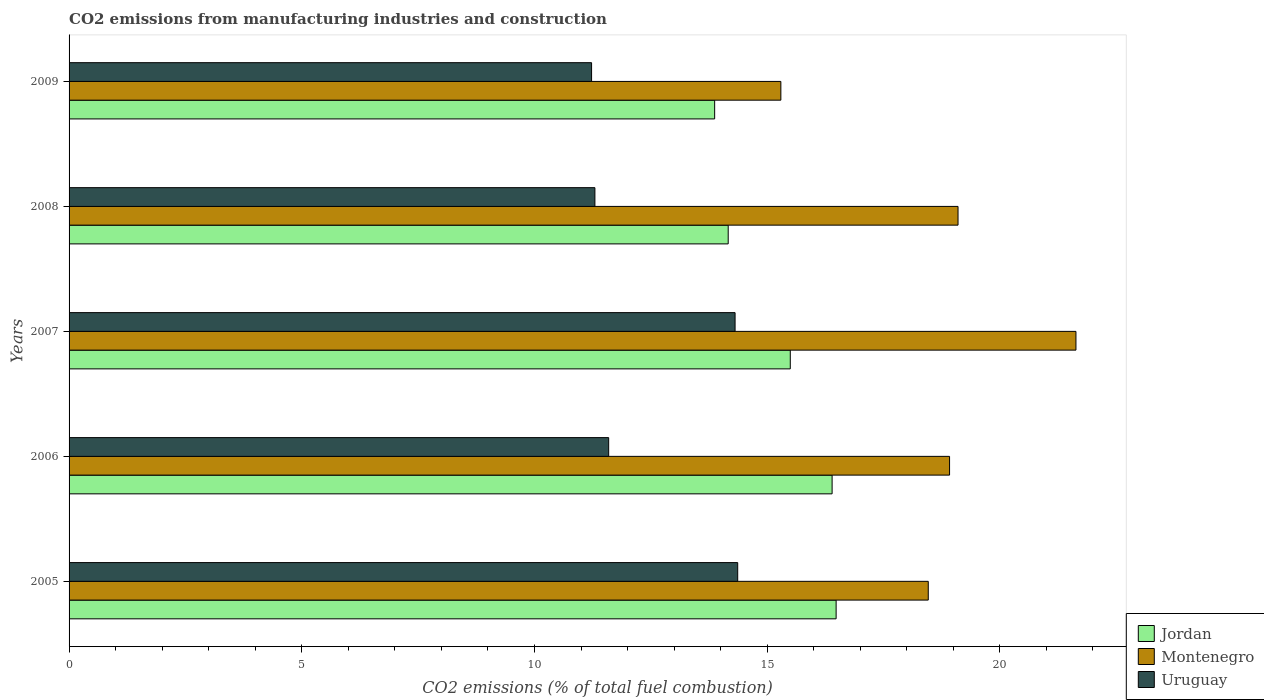How many different coloured bars are there?
Keep it short and to the point. 3. How many bars are there on the 5th tick from the top?
Your answer should be very brief. 3. How many bars are there on the 1st tick from the bottom?
Offer a very short reply. 3. What is the label of the 3rd group of bars from the top?
Offer a terse response. 2007. In how many cases, is the number of bars for a given year not equal to the number of legend labels?
Your answer should be very brief. 0. What is the amount of CO2 emitted in Uruguay in 2008?
Make the answer very short. 11.3. Across all years, what is the maximum amount of CO2 emitted in Jordan?
Make the answer very short. 16.48. Across all years, what is the minimum amount of CO2 emitted in Montenegro?
Offer a very short reply. 15.29. In which year was the amount of CO2 emitted in Jordan minimum?
Keep it short and to the point. 2009. What is the total amount of CO2 emitted in Uruguay in the graph?
Your response must be concise. 62.8. What is the difference between the amount of CO2 emitted in Uruguay in 2008 and that in 2009?
Your response must be concise. 0.07. What is the difference between the amount of CO2 emitted in Uruguay in 2006 and the amount of CO2 emitted in Montenegro in 2005?
Keep it short and to the point. -6.87. What is the average amount of CO2 emitted in Montenegro per year?
Keep it short and to the point. 18.68. In the year 2007, what is the difference between the amount of CO2 emitted in Jordan and amount of CO2 emitted in Uruguay?
Offer a terse response. 1.19. What is the ratio of the amount of CO2 emitted in Montenegro in 2005 to that in 2008?
Give a very brief answer. 0.97. Is the amount of CO2 emitted in Uruguay in 2006 less than that in 2008?
Give a very brief answer. No. What is the difference between the highest and the second highest amount of CO2 emitted in Montenegro?
Give a very brief answer. 2.53. What is the difference between the highest and the lowest amount of CO2 emitted in Jordan?
Offer a very short reply. 2.61. Is the sum of the amount of CO2 emitted in Uruguay in 2006 and 2009 greater than the maximum amount of CO2 emitted in Jordan across all years?
Keep it short and to the point. Yes. What does the 2nd bar from the top in 2009 represents?
Your response must be concise. Montenegro. What does the 1st bar from the bottom in 2007 represents?
Provide a short and direct response. Jordan. Are all the bars in the graph horizontal?
Offer a terse response. Yes. Are the values on the major ticks of X-axis written in scientific E-notation?
Keep it short and to the point. No. Does the graph contain any zero values?
Give a very brief answer. No. Does the graph contain grids?
Your response must be concise. No. Where does the legend appear in the graph?
Give a very brief answer. Bottom right. What is the title of the graph?
Make the answer very short. CO2 emissions from manufacturing industries and construction. Does "Turkmenistan" appear as one of the legend labels in the graph?
Keep it short and to the point. No. What is the label or title of the X-axis?
Your answer should be very brief. CO2 emissions (% of total fuel combustion). What is the label or title of the Y-axis?
Make the answer very short. Years. What is the CO2 emissions (% of total fuel combustion) in Jordan in 2005?
Your response must be concise. 16.48. What is the CO2 emissions (% of total fuel combustion) in Montenegro in 2005?
Make the answer very short. 18.46. What is the CO2 emissions (% of total fuel combustion) in Uruguay in 2005?
Make the answer very short. 14.37. What is the CO2 emissions (% of total fuel combustion) in Jordan in 2006?
Provide a succinct answer. 16.4. What is the CO2 emissions (% of total fuel combustion) of Montenegro in 2006?
Offer a terse response. 18.92. What is the CO2 emissions (% of total fuel combustion) of Uruguay in 2006?
Provide a short and direct response. 11.59. What is the CO2 emissions (% of total fuel combustion) of Jordan in 2007?
Keep it short and to the point. 15.5. What is the CO2 emissions (% of total fuel combustion) in Montenegro in 2007?
Keep it short and to the point. 21.63. What is the CO2 emissions (% of total fuel combustion) of Uruguay in 2007?
Offer a very short reply. 14.31. What is the CO2 emissions (% of total fuel combustion) of Jordan in 2008?
Keep it short and to the point. 14.16. What is the CO2 emissions (% of total fuel combustion) of Montenegro in 2008?
Provide a short and direct response. 19.1. What is the CO2 emissions (% of total fuel combustion) in Uruguay in 2008?
Keep it short and to the point. 11.3. What is the CO2 emissions (% of total fuel combustion) of Jordan in 2009?
Offer a very short reply. 13.87. What is the CO2 emissions (% of total fuel combustion) in Montenegro in 2009?
Provide a succinct answer. 15.29. What is the CO2 emissions (% of total fuel combustion) in Uruguay in 2009?
Provide a succinct answer. 11.23. Across all years, what is the maximum CO2 emissions (% of total fuel combustion) in Jordan?
Offer a terse response. 16.48. Across all years, what is the maximum CO2 emissions (% of total fuel combustion) of Montenegro?
Keep it short and to the point. 21.63. Across all years, what is the maximum CO2 emissions (% of total fuel combustion) in Uruguay?
Your answer should be compact. 14.37. Across all years, what is the minimum CO2 emissions (% of total fuel combustion) of Jordan?
Give a very brief answer. 13.87. Across all years, what is the minimum CO2 emissions (% of total fuel combustion) of Montenegro?
Keep it short and to the point. 15.29. Across all years, what is the minimum CO2 emissions (% of total fuel combustion) of Uruguay?
Your answer should be very brief. 11.23. What is the total CO2 emissions (% of total fuel combustion) in Jordan in the graph?
Offer a very short reply. 76.41. What is the total CO2 emissions (% of total fuel combustion) in Montenegro in the graph?
Keep it short and to the point. 93.41. What is the total CO2 emissions (% of total fuel combustion) in Uruguay in the graph?
Your answer should be very brief. 62.8. What is the difference between the CO2 emissions (% of total fuel combustion) in Jordan in 2005 and that in 2006?
Ensure brevity in your answer.  0.09. What is the difference between the CO2 emissions (% of total fuel combustion) of Montenegro in 2005 and that in 2006?
Offer a terse response. -0.46. What is the difference between the CO2 emissions (% of total fuel combustion) of Uruguay in 2005 and that in 2006?
Your answer should be compact. 2.77. What is the difference between the CO2 emissions (% of total fuel combustion) of Jordan in 2005 and that in 2007?
Make the answer very short. 0.99. What is the difference between the CO2 emissions (% of total fuel combustion) in Montenegro in 2005 and that in 2007?
Your answer should be very brief. -3.17. What is the difference between the CO2 emissions (% of total fuel combustion) of Uruguay in 2005 and that in 2007?
Offer a very short reply. 0.06. What is the difference between the CO2 emissions (% of total fuel combustion) in Jordan in 2005 and that in 2008?
Offer a terse response. 2.32. What is the difference between the CO2 emissions (% of total fuel combustion) in Montenegro in 2005 and that in 2008?
Ensure brevity in your answer.  -0.64. What is the difference between the CO2 emissions (% of total fuel combustion) in Uruguay in 2005 and that in 2008?
Ensure brevity in your answer.  3.07. What is the difference between the CO2 emissions (% of total fuel combustion) in Jordan in 2005 and that in 2009?
Your answer should be compact. 2.61. What is the difference between the CO2 emissions (% of total fuel combustion) in Montenegro in 2005 and that in 2009?
Make the answer very short. 3.17. What is the difference between the CO2 emissions (% of total fuel combustion) of Uruguay in 2005 and that in 2009?
Make the answer very short. 3.14. What is the difference between the CO2 emissions (% of total fuel combustion) of Jordan in 2006 and that in 2007?
Give a very brief answer. 0.9. What is the difference between the CO2 emissions (% of total fuel combustion) in Montenegro in 2006 and that in 2007?
Your answer should be very brief. -2.72. What is the difference between the CO2 emissions (% of total fuel combustion) of Uruguay in 2006 and that in 2007?
Make the answer very short. -2.72. What is the difference between the CO2 emissions (% of total fuel combustion) in Jordan in 2006 and that in 2008?
Provide a short and direct response. 2.23. What is the difference between the CO2 emissions (% of total fuel combustion) in Montenegro in 2006 and that in 2008?
Offer a terse response. -0.18. What is the difference between the CO2 emissions (% of total fuel combustion) of Uruguay in 2006 and that in 2008?
Provide a succinct answer. 0.3. What is the difference between the CO2 emissions (% of total fuel combustion) in Jordan in 2006 and that in 2009?
Your answer should be compact. 2.52. What is the difference between the CO2 emissions (% of total fuel combustion) of Montenegro in 2006 and that in 2009?
Ensure brevity in your answer.  3.62. What is the difference between the CO2 emissions (% of total fuel combustion) of Uruguay in 2006 and that in 2009?
Offer a terse response. 0.37. What is the difference between the CO2 emissions (% of total fuel combustion) of Jordan in 2007 and that in 2008?
Ensure brevity in your answer.  1.33. What is the difference between the CO2 emissions (% of total fuel combustion) of Montenegro in 2007 and that in 2008?
Provide a short and direct response. 2.53. What is the difference between the CO2 emissions (% of total fuel combustion) in Uruguay in 2007 and that in 2008?
Provide a succinct answer. 3.01. What is the difference between the CO2 emissions (% of total fuel combustion) in Jordan in 2007 and that in 2009?
Offer a terse response. 1.62. What is the difference between the CO2 emissions (% of total fuel combustion) in Montenegro in 2007 and that in 2009?
Ensure brevity in your answer.  6.34. What is the difference between the CO2 emissions (% of total fuel combustion) of Uruguay in 2007 and that in 2009?
Offer a terse response. 3.08. What is the difference between the CO2 emissions (% of total fuel combustion) of Jordan in 2008 and that in 2009?
Keep it short and to the point. 0.29. What is the difference between the CO2 emissions (% of total fuel combustion) of Montenegro in 2008 and that in 2009?
Keep it short and to the point. 3.81. What is the difference between the CO2 emissions (% of total fuel combustion) of Uruguay in 2008 and that in 2009?
Keep it short and to the point. 0.07. What is the difference between the CO2 emissions (% of total fuel combustion) of Jordan in 2005 and the CO2 emissions (% of total fuel combustion) of Montenegro in 2006?
Give a very brief answer. -2.44. What is the difference between the CO2 emissions (% of total fuel combustion) of Jordan in 2005 and the CO2 emissions (% of total fuel combustion) of Uruguay in 2006?
Give a very brief answer. 4.89. What is the difference between the CO2 emissions (% of total fuel combustion) in Montenegro in 2005 and the CO2 emissions (% of total fuel combustion) in Uruguay in 2006?
Ensure brevity in your answer.  6.87. What is the difference between the CO2 emissions (% of total fuel combustion) in Jordan in 2005 and the CO2 emissions (% of total fuel combustion) in Montenegro in 2007?
Your response must be concise. -5.15. What is the difference between the CO2 emissions (% of total fuel combustion) of Jordan in 2005 and the CO2 emissions (% of total fuel combustion) of Uruguay in 2007?
Make the answer very short. 2.17. What is the difference between the CO2 emissions (% of total fuel combustion) of Montenegro in 2005 and the CO2 emissions (% of total fuel combustion) of Uruguay in 2007?
Offer a very short reply. 4.15. What is the difference between the CO2 emissions (% of total fuel combustion) in Jordan in 2005 and the CO2 emissions (% of total fuel combustion) in Montenegro in 2008?
Your response must be concise. -2.62. What is the difference between the CO2 emissions (% of total fuel combustion) in Jordan in 2005 and the CO2 emissions (% of total fuel combustion) in Uruguay in 2008?
Give a very brief answer. 5.18. What is the difference between the CO2 emissions (% of total fuel combustion) in Montenegro in 2005 and the CO2 emissions (% of total fuel combustion) in Uruguay in 2008?
Ensure brevity in your answer.  7.16. What is the difference between the CO2 emissions (% of total fuel combustion) of Jordan in 2005 and the CO2 emissions (% of total fuel combustion) of Montenegro in 2009?
Your response must be concise. 1.19. What is the difference between the CO2 emissions (% of total fuel combustion) of Jordan in 2005 and the CO2 emissions (% of total fuel combustion) of Uruguay in 2009?
Keep it short and to the point. 5.25. What is the difference between the CO2 emissions (% of total fuel combustion) of Montenegro in 2005 and the CO2 emissions (% of total fuel combustion) of Uruguay in 2009?
Your answer should be compact. 7.23. What is the difference between the CO2 emissions (% of total fuel combustion) in Jordan in 2006 and the CO2 emissions (% of total fuel combustion) in Montenegro in 2007?
Provide a succinct answer. -5.24. What is the difference between the CO2 emissions (% of total fuel combustion) in Jordan in 2006 and the CO2 emissions (% of total fuel combustion) in Uruguay in 2007?
Offer a terse response. 2.08. What is the difference between the CO2 emissions (% of total fuel combustion) in Montenegro in 2006 and the CO2 emissions (% of total fuel combustion) in Uruguay in 2007?
Your answer should be compact. 4.61. What is the difference between the CO2 emissions (% of total fuel combustion) in Jordan in 2006 and the CO2 emissions (% of total fuel combustion) in Montenegro in 2008?
Provide a short and direct response. -2.71. What is the difference between the CO2 emissions (% of total fuel combustion) in Jordan in 2006 and the CO2 emissions (% of total fuel combustion) in Uruguay in 2008?
Your response must be concise. 5.1. What is the difference between the CO2 emissions (% of total fuel combustion) in Montenegro in 2006 and the CO2 emissions (% of total fuel combustion) in Uruguay in 2008?
Provide a succinct answer. 7.62. What is the difference between the CO2 emissions (% of total fuel combustion) in Jordan in 2006 and the CO2 emissions (% of total fuel combustion) in Montenegro in 2009?
Your answer should be compact. 1.1. What is the difference between the CO2 emissions (% of total fuel combustion) of Jordan in 2006 and the CO2 emissions (% of total fuel combustion) of Uruguay in 2009?
Offer a terse response. 5.17. What is the difference between the CO2 emissions (% of total fuel combustion) in Montenegro in 2006 and the CO2 emissions (% of total fuel combustion) in Uruguay in 2009?
Your answer should be compact. 7.69. What is the difference between the CO2 emissions (% of total fuel combustion) of Jordan in 2007 and the CO2 emissions (% of total fuel combustion) of Montenegro in 2008?
Offer a very short reply. -3.6. What is the difference between the CO2 emissions (% of total fuel combustion) in Jordan in 2007 and the CO2 emissions (% of total fuel combustion) in Uruguay in 2008?
Your answer should be very brief. 4.2. What is the difference between the CO2 emissions (% of total fuel combustion) of Montenegro in 2007 and the CO2 emissions (% of total fuel combustion) of Uruguay in 2008?
Provide a succinct answer. 10.34. What is the difference between the CO2 emissions (% of total fuel combustion) in Jordan in 2007 and the CO2 emissions (% of total fuel combustion) in Montenegro in 2009?
Offer a very short reply. 0.2. What is the difference between the CO2 emissions (% of total fuel combustion) in Jordan in 2007 and the CO2 emissions (% of total fuel combustion) in Uruguay in 2009?
Your answer should be very brief. 4.27. What is the difference between the CO2 emissions (% of total fuel combustion) in Montenegro in 2007 and the CO2 emissions (% of total fuel combustion) in Uruguay in 2009?
Give a very brief answer. 10.41. What is the difference between the CO2 emissions (% of total fuel combustion) in Jordan in 2008 and the CO2 emissions (% of total fuel combustion) in Montenegro in 2009?
Your response must be concise. -1.13. What is the difference between the CO2 emissions (% of total fuel combustion) of Jordan in 2008 and the CO2 emissions (% of total fuel combustion) of Uruguay in 2009?
Keep it short and to the point. 2.94. What is the difference between the CO2 emissions (% of total fuel combustion) of Montenegro in 2008 and the CO2 emissions (% of total fuel combustion) of Uruguay in 2009?
Offer a terse response. 7.87. What is the average CO2 emissions (% of total fuel combustion) of Jordan per year?
Offer a very short reply. 15.28. What is the average CO2 emissions (% of total fuel combustion) in Montenegro per year?
Your response must be concise. 18.68. What is the average CO2 emissions (% of total fuel combustion) of Uruguay per year?
Your answer should be compact. 12.56. In the year 2005, what is the difference between the CO2 emissions (% of total fuel combustion) of Jordan and CO2 emissions (% of total fuel combustion) of Montenegro?
Your response must be concise. -1.98. In the year 2005, what is the difference between the CO2 emissions (% of total fuel combustion) of Jordan and CO2 emissions (% of total fuel combustion) of Uruguay?
Provide a short and direct response. 2.12. In the year 2005, what is the difference between the CO2 emissions (% of total fuel combustion) of Montenegro and CO2 emissions (% of total fuel combustion) of Uruguay?
Provide a succinct answer. 4.09. In the year 2006, what is the difference between the CO2 emissions (% of total fuel combustion) of Jordan and CO2 emissions (% of total fuel combustion) of Montenegro?
Ensure brevity in your answer.  -2.52. In the year 2006, what is the difference between the CO2 emissions (% of total fuel combustion) in Jordan and CO2 emissions (% of total fuel combustion) in Uruguay?
Offer a very short reply. 4.8. In the year 2006, what is the difference between the CO2 emissions (% of total fuel combustion) of Montenegro and CO2 emissions (% of total fuel combustion) of Uruguay?
Ensure brevity in your answer.  7.32. In the year 2007, what is the difference between the CO2 emissions (% of total fuel combustion) of Jordan and CO2 emissions (% of total fuel combustion) of Montenegro?
Keep it short and to the point. -6.14. In the year 2007, what is the difference between the CO2 emissions (% of total fuel combustion) in Jordan and CO2 emissions (% of total fuel combustion) in Uruguay?
Offer a very short reply. 1.19. In the year 2007, what is the difference between the CO2 emissions (% of total fuel combustion) of Montenegro and CO2 emissions (% of total fuel combustion) of Uruguay?
Make the answer very short. 7.32. In the year 2008, what is the difference between the CO2 emissions (% of total fuel combustion) in Jordan and CO2 emissions (% of total fuel combustion) in Montenegro?
Give a very brief answer. -4.94. In the year 2008, what is the difference between the CO2 emissions (% of total fuel combustion) of Jordan and CO2 emissions (% of total fuel combustion) of Uruguay?
Offer a terse response. 2.86. In the year 2008, what is the difference between the CO2 emissions (% of total fuel combustion) of Montenegro and CO2 emissions (% of total fuel combustion) of Uruguay?
Offer a very short reply. 7.8. In the year 2009, what is the difference between the CO2 emissions (% of total fuel combustion) in Jordan and CO2 emissions (% of total fuel combustion) in Montenegro?
Keep it short and to the point. -1.42. In the year 2009, what is the difference between the CO2 emissions (% of total fuel combustion) in Jordan and CO2 emissions (% of total fuel combustion) in Uruguay?
Your answer should be very brief. 2.64. In the year 2009, what is the difference between the CO2 emissions (% of total fuel combustion) of Montenegro and CO2 emissions (% of total fuel combustion) of Uruguay?
Offer a very short reply. 4.07. What is the ratio of the CO2 emissions (% of total fuel combustion) in Montenegro in 2005 to that in 2006?
Provide a short and direct response. 0.98. What is the ratio of the CO2 emissions (% of total fuel combustion) of Uruguay in 2005 to that in 2006?
Offer a very short reply. 1.24. What is the ratio of the CO2 emissions (% of total fuel combustion) of Jordan in 2005 to that in 2007?
Provide a short and direct response. 1.06. What is the ratio of the CO2 emissions (% of total fuel combustion) of Montenegro in 2005 to that in 2007?
Your answer should be compact. 0.85. What is the ratio of the CO2 emissions (% of total fuel combustion) in Uruguay in 2005 to that in 2007?
Make the answer very short. 1. What is the ratio of the CO2 emissions (% of total fuel combustion) in Jordan in 2005 to that in 2008?
Give a very brief answer. 1.16. What is the ratio of the CO2 emissions (% of total fuel combustion) in Montenegro in 2005 to that in 2008?
Your response must be concise. 0.97. What is the ratio of the CO2 emissions (% of total fuel combustion) of Uruguay in 2005 to that in 2008?
Offer a very short reply. 1.27. What is the ratio of the CO2 emissions (% of total fuel combustion) of Jordan in 2005 to that in 2009?
Keep it short and to the point. 1.19. What is the ratio of the CO2 emissions (% of total fuel combustion) in Montenegro in 2005 to that in 2009?
Keep it short and to the point. 1.21. What is the ratio of the CO2 emissions (% of total fuel combustion) of Uruguay in 2005 to that in 2009?
Your response must be concise. 1.28. What is the ratio of the CO2 emissions (% of total fuel combustion) of Jordan in 2006 to that in 2007?
Give a very brief answer. 1.06. What is the ratio of the CO2 emissions (% of total fuel combustion) in Montenegro in 2006 to that in 2007?
Give a very brief answer. 0.87. What is the ratio of the CO2 emissions (% of total fuel combustion) of Uruguay in 2006 to that in 2007?
Your answer should be very brief. 0.81. What is the ratio of the CO2 emissions (% of total fuel combustion) in Jordan in 2006 to that in 2008?
Your answer should be compact. 1.16. What is the ratio of the CO2 emissions (% of total fuel combustion) of Uruguay in 2006 to that in 2008?
Give a very brief answer. 1.03. What is the ratio of the CO2 emissions (% of total fuel combustion) in Jordan in 2006 to that in 2009?
Give a very brief answer. 1.18. What is the ratio of the CO2 emissions (% of total fuel combustion) in Montenegro in 2006 to that in 2009?
Your response must be concise. 1.24. What is the ratio of the CO2 emissions (% of total fuel combustion) of Uruguay in 2006 to that in 2009?
Your response must be concise. 1.03. What is the ratio of the CO2 emissions (% of total fuel combustion) in Jordan in 2007 to that in 2008?
Your answer should be very brief. 1.09. What is the ratio of the CO2 emissions (% of total fuel combustion) in Montenegro in 2007 to that in 2008?
Provide a succinct answer. 1.13. What is the ratio of the CO2 emissions (% of total fuel combustion) of Uruguay in 2007 to that in 2008?
Your response must be concise. 1.27. What is the ratio of the CO2 emissions (% of total fuel combustion) in Jordan in 2007 to that in 2009?
Ensure brevity in your answer.  1.12. What is the ratio of the CO2 emissions (% of total fuel combustion) of Montenegro in 2007 to that in 2009?
Make the answer very short. 1.41. What is the ratio of the CO2 emissions (% of total fuel combustion) in Uruguay in 2007 to that in 2009?
Your answer should be compact. 1.27. What is the ratio of the CO2 emissions (% of total fuel combustion) of Montenegro in 2008 to that in 2009?
Offer a very short reply. 1.25. What is the ratio of the CO2 emissions (% of total fuel combustion) of Uruguay in 2008 to that in 2009?
Offer a very short reply. 1.01. What is the difference between the highest and the second highest CO2 emissions (% of total fuel combustion) of Jordan?
Your answer should be compact. 0.09. What is the difference between the highest and the second highest CO2 emissions (% of total fuel combustion) of Montenegro?
Give a very brief answer. 2.53. What is the difference between the highest and the second highest CO2 emissions (% of total fuel combustion) in Uruguay?
Provide a short and direct response. 0.06. What is the difference between the highest and the lowest CO2 emissions (% of total fuel combustion) in Jordan?
Ensure brevity in your answer.  2.61. What is the difference between the highest and the lowest CO2 emissions (% of total fuel combustion) of Montenegro?
Offer a terse response. 6.34. What is the difference between the highest and the lowest CO2 emissions (% of total fuel combustion) of Uruguay?
Offer a terse response. 3.14. 